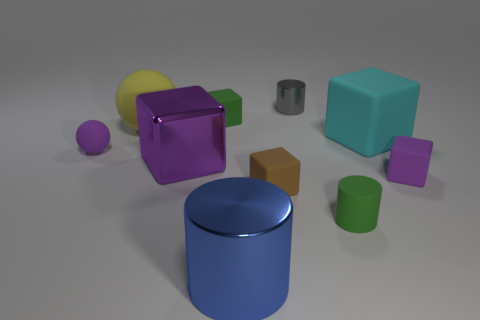Subtract all tiny brown cubes. How many cubes are left? 4 Subtract all green cylinders. How many cylinders are left? 2 Subtract all gray cubes. Subtract all tiny cubes. How many objects are left? 7 Add 8 green matte cylinders. How many green matte cylinders are left? 9 Add 1 tiny gray things. How many tiny gray things exist? 2 Subtract 1 green cubes. How many objects are left? 9 Subtract all spheres. How many objects are left? 8 Subtract 3 cylinders. How many cylinders are left? 0 Subtract all blue cylinders. Subtract all gray spheres. How many cylinders are left? 2 Subtract all blue cubes. How many green cylinders are left? 1 